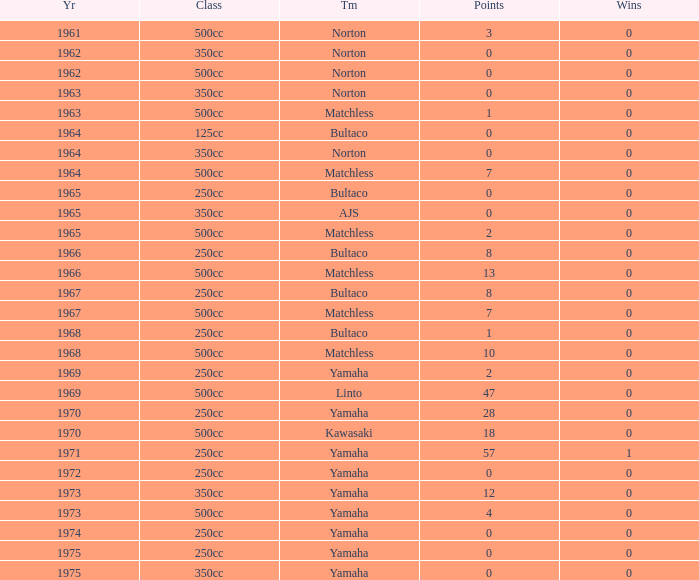What is the sum of all points in 1975 with 0 wins? None. 